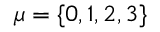Convert formula to latex. <formula><loc_0><loc_0><loc_500><loc_500>\mu = \{ 0 , 1 , 2 , 3 \}</formula> 